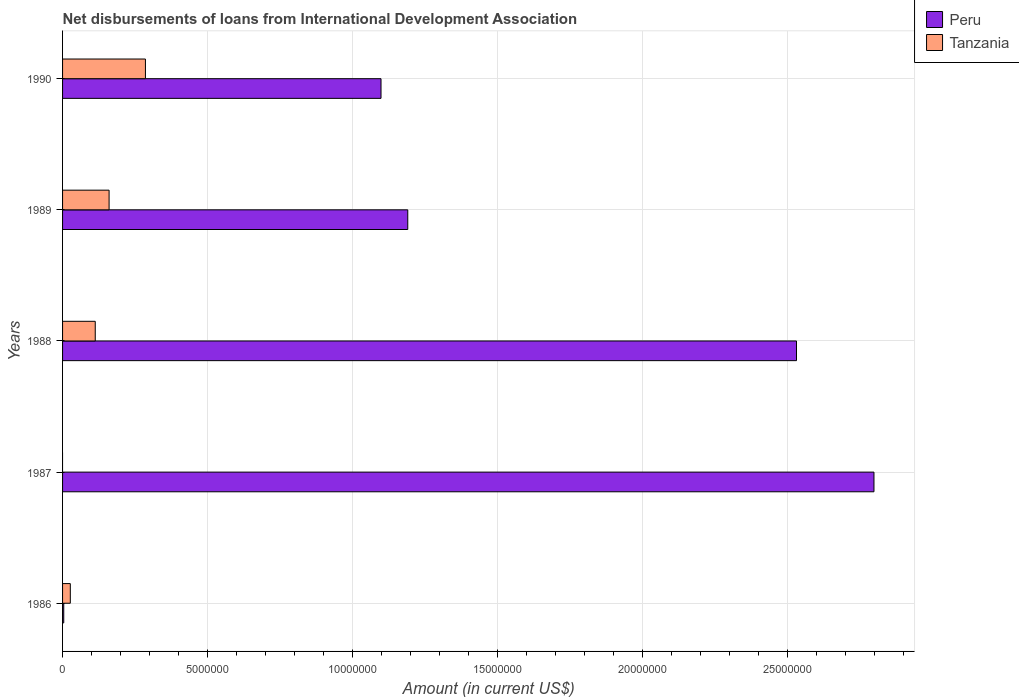How many different coloured bars are there?
Ensure brevity in your answer.  2. Are the number of bars per tick equal to the number of legend labels?
Your answer should be compact. No. Are the number of bars on each tick of the Y-axis equal?
Your response must be concise. No. How many bars are there on the 2nd tick from the top?
Provide a succinct answer. 2. How many bars are there on the 4th tick from the bottom?
Offer a terse response. 2. What is the amount of loans disbursed in Peru in 1986?
Your response must be concise. 4.10e+04. Across all years, what is the maximum amount of loans disbursed in Peru?
Make the answer very short. 2.80e+07. Across all years, what is the minimum amount of loans disbursed in Tanzania?
Your response must be concise. 0. What is the total amount of loans disbursed in Tanzania in the graph?
Give a very brief answer. 5.86e+06. What is the difference between the amount of loans disbursed in Tanzania in 1986 and that in 1990?
Your answer should be very brief. -2.59e+06. What is the difference between the amount of loans disbursed in Peru in 1987 and the amount of loans disbursed in Tanzania in 1989?
Your answer should be compact. 2.64e+07. What is the average amount of loans disbursed in Peru per year?
Offer a very short reply. 1.52e+07. In the year 1986, what is the difference between the amount of loans disbursed in Tanzania and amount of loans disbursed in Peru?
Your answer should be compact. 2.26e+05. What is the ratio of the amount of loans disbursed in Tanzania in 1988 to that in 1990?
Provide a short and direct response. 0.39. Is the amount of loans disbursed in Tanzania in 1989 less than that in 1990?
Your response must be concise. Yes. What is the difference between the highest and the second highest amount of loans disbursed in Peru?
Make the answer very short. 2.67e+06. What is the difference between the highest and the lowest amount of loans disbursed in Peru?
Your answer should be very brief. 2.79e+07. In how many years, is the amount of loans disbursed in Tanzania greater than the average amount of loans disbursed in Tanzania taken over all years?
Your answer should be very brief. 2. Is the sum of the amount of loans disbursed in Peru in 1987 and 1988 greater than the maximum amount of loans disbursed in Tanzania across all years?
Make the answer very short. Yes. How many years are there in the graph?
Your response must be concise. 5. What is the difference between two consecutive major ticks on the X-axis?
Your answer should be compact. 5.00e+06. Are the values on the major ticks of X-axis written in scientific E-notation?
Offer a very short reply. No. Does the graph contain any zero values?
Your answer should be very brief. Yes. Does the graph contain grids?
Your answer should be very brief. Yes. Where does the legend appear in the graph?
Ensure brevity in your answer.  Top right. How many legend labels are there?
Provide a succinct answer. 2. What is the title of the graph?
Ensure brevity in your answer.  Net disbursements of loans from International Development Association. What is the label or title of the X-axis?
Offer a terse response. Amount (in current US$). What is the Amount (in current US$) of Peru in 1986?
Your answer should be very brief. 4.10e+04. What is the Amount (in current US$) of Tanzania in 1986?
Your answer should be very brief. 2.67e+05. What is the Amount (in current US$) of Peru in 1987?
Offer a terse response. 2.80e+07. What is the Amount (in current US$) in Peru in 1988?
Your answer should be very brief. 2.53e+07. What is the Amount (in current US$) of Tanzania in 1988?
Ensure brevity in your answer.  1.13e+06. What is the Amount (in current US$) in Peru in 1989?
Provide a short and direct response. 1.19e+07. What is the Amount (in current US$) in Tanzania in 1989?
Offer a very short reply. 1.60e+06. What is the Amount (in current US$) of Peru in 1990?
Your answer should be compact. 1.10e+07. What is the Amount (in current US$) of Tanzania in 1990?
Your response must be concise. 2.86e+06. Across all years, what is the maximum Amount (in current US$) of Peru?
Make the answer very short. 2.80e+07. Across all years, what is the maximum Amount (in current US$) of Tanzania?
Ensure brevity in your answer.  2.86e+06. Across all years, what is the minimum Amount (in current US$) of Peru?
Give a very brief answer. 4.10e+04. What is the total Amount (in current US$) in Peru in the graph?
Provide a succinct answer. 7.62e+07. What is the total Amount (in current US$) in Tanzania in the graph?
Give a very brief answer. 5.86e+06. What is the difference between the Amount (in current US$) in Peru in 1986 and that in 1987?
Ensure brevity in your answer.  -2.79e+07. What is the difference between the Amount (in current US$) in Peru in 1986 and that in 1988?
Your response must be concise. -2.53e+07. What is the difference between the Amount (in current US$) of Tanzania in 1986 and that in 1988?
Keep it short and to the point. -8.60e+05. What is the difference between the Amount (in current US$) of Peru in 1986 and that in 1989?
Offer a terse response. -1.19e+07. What is the difference between the Amount (in current US$) of Tanzania in 1986 and that in 1989?
Your response must be concise. -1.34e+06. What is the difference between the Amount (in current US$) in Peru in 1986 and that in 1990?
Keep it short and to the point. -1.09e+07. What is the difference between the Amount (in current US$) of Tanzania in 1986 and that in 1990?
Keep it short and to the point. -2.59e+06. What is the difference between the Amount (in current US$) in Peru in 1987 and that in 1988?
Keep it short and to the point. 2.67e+06. What is the difference between the Amount (in current US$) of Peru in 1987 and that in 1989?
Your response must be concise. 1.61e+07. What is the difference between the Amount (in current US$) of Peru in 1987 and that in 1990?
Offer a very short reply. 1.70e+07. What is the difference between the Amount (in current US$) of Peru in 1988 and that in 1989?
Your answer should be compact. 1.34e+07. What is the difference between the Amount (in current US$) of Tanzania in 1988 and that in 1989?
Provide a succinct answer. -4.77e+05. What is the difference between the Amount (in current US$) of Peru in 1988 and that in 1990?
Make the answer very short. 1.43e+07. What is the difference between the Amount (in current US$) of Tanzania in 1988 and that in 1990?
Offer a terse response. -1.73e+06. What is the difference between the Amount (in current US$) of Peru in 1989 and that in 1990?
Provide a short and direct response. 9.22e+05. What is the difference between the Amount (in current US$) in Tanzania in 1989 and that in 1990?
Give a very brief answer. -1.25e+06. What is the difference between the Amount (in current US$) in Peru in 1986 and the Amount (in current US$) in Tanzania in 1988?
Your answer should be compact. -1.09e+06. What is the difference between the Amount (in current US$) in Peru in 1986 and the Amount (in current US$) in Tanzania in 1989?
Provide a succinct answer. -1.56e+06. What is the difference between the Amount (in current US$) in Peru in 1986 and the Amount (in current US$) in Tanzania in 1990?
Make the answer very short. -2.82e+06. What is the difference between the Amount (in current US$) of Peru in 1987 and the Amount (in current US$) of Tanzania in 1988?
Offer a very short reply. 2.68e+07. What is the difference between the Amount (in current US$) of Peru in 1987 and the Amount (in current US$) of Tanzania in 1989?
Offer a terse response. 2.64e+07. What is the difference between the Amount (in current US$) in Peru in 1987 and the Amount (in current US$) in Tanzania in 1990?
Make the answer very short. 2.51e+07. What is the difference between the Amount (in current US$) in Peru in 1988 and the Amount (in current US$) in Tanzania in 1989?
Give a very brief answer. 2.37e+07. What is the difference between the Amount (in current US$) of Peru in 1988 and the Amount (in current US$) of Tanzania in 1990?
Offer a very short reply. 2.24e+07. What is the difference between the Amount (in current US$) in Peru in 1989 and the Amount (in current US$) in Tanzania in 1990?
Give a very brief answer. 9.04e+06. What is the average Amount (in current US$) in Peru per year?
Keep it short and to the point. 1.52e+07. What is the average Amount (in current US$) in Tanzania per year?
Give a very brief answer. 1.17e+06. In the year 1986, what is the difference between the Amount (in current US$) in Peru and Amount (in current US$) in Tanzania?
Offer a very short reply. -2.26e+05. In the year 1988, what is the difference between the Amount (in current US$) of Peru and Amount (in current US$) of Tanzania?
Offer a very short reply. 2.42e+07. In the year 1989, what is the difference between the Amount (in current US$) of Peru and Amount (in current US$) of Tanzania?
Give a very brief answer. 1.03e+07. In the year 1990, what is the difference between the Amount (in current US$) in Peru and Amount (in current US$) in Tanzania?
Offer a very short reply. 8.12e+06. What is the ratio of the Amount (in current US$) in Peru in 1986 to that in 1987?
Your answer should be compact. 0. What is the ratio of the Amount (in current US$) in Peru in 1986 to that in 1988?
Your answer should be compact. 0. What is the ratio of the Amount (in current US$) in Tanzania in 1986 to that in 1988?
Offer a terse response. 0.24. What is the ratio of the Amount (in current US$) of Peru in 1986 to that in 1989?
Offer a very short reply. 0. What is the ratio of the Amount (in current US$) of Tanzania in 1986 to that in 1989?
Your answer should be very brief. 0.17. What is the ratio of the Amount (in current US$) in Peru in 1986 to that in 1990?
Provide a succinct answer. 0. What is the ratio of the Amount (in current US$) of Tanzania in 1986 to that in 1990?
Your answer should be compact. 0.09. What is the ratio of the Amount (in current US$) in Peru in 1987 to that in 1988?
Your answer should be compact. 1.11. What is the ratio of the Amount (in current US$) of Peru in 1987 to that in 1989?
Provide a succinct answer. 2.35. What is the ratio of the Amount (in current US$) in Peru in 1987 to that in 1990?
Ensure brevity in your answer.  2.55. What is the ratio of the Amount (in current US$) in Peru in 1988 to that in 1989?
Provide a succinct answer. 2.13. What is the ratio of the Amount (in current US$) in Tanzania in 1988 to that in 1989?
Keep it short and to the point. 0.7. What is the ratio of the Amount (in current US$) of Peru in 1988 to that in 1990?
Make the answer very short. 2.3. What is the ratio of the Amount (in current US$) of Tanzania in 1988 to that in 1990?
Your answer should be very brief. 0.39. What is the ratio of the Amount (in current US$) of Peru in 1989 to that in 1990?
Your response must be concise. 1.08. What is the ratio of the Amount (in current US$) of Tanzania in 1989 to that in 1990?
Ensure brevity in your answer.  0.56. What is the difference between the highest and the second highest Amount (in current US$) in Peru?
Make the answer very short. 2.67e+06. What is the difference between the highest and the second highest Amount (in current US$) in Tanzania?
Ensure brevity in your answer.  1.25e+06. What is the difference between the highest and the lowest Amount (in current US$) in Peru?
Make the answer very short. 2.79e+07. What is the difference between the highest and the lowest Amount (in current US$) in Tanzania?
Give a very brief answer. 2.86e+06. 